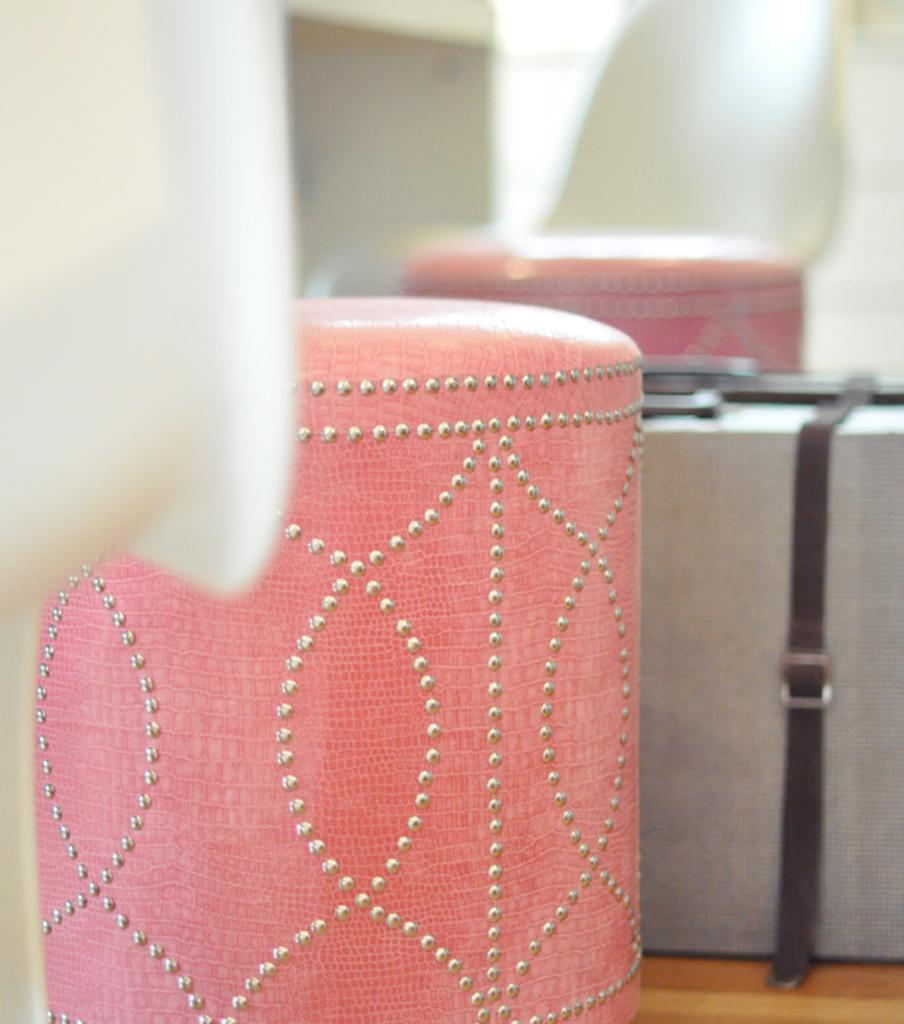What is the color and pattern of the object in the image? A: The object in the image is pink with silver dots. What can be seen on the right side of the image? There is a briefcase on the right side of the image. How would you describe the background of the image? The background of the image is blurred. What scent can be detected from the object in the image? There is no information about the scent of the object in the image, as it is not mentioned in the provided facts. 